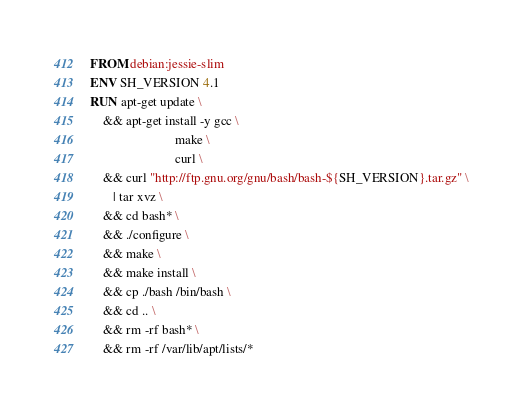<code> <loc_0><loc_0><loc_500><loc_500><_Dockerfile_>FROM debian:jessie-slim
ENV SH_VERSION 4.1
RUN apt-get update \
    && apt-get install -y gcc \
                          make \
                          curl \
    && curl "http://ftp.gnu.org/gnu/bash/bash-${SH_VERSION}.tar.gz" \
       | tar xvz \
    && cd bash* \
    && ./configure \
    && make \
    && make install \
    && cp ./bash /bin/bash \
    && cd .. \
    && rm -rf bash* \
    && rm -rf /var/lib/apt/lists/*
</code> 